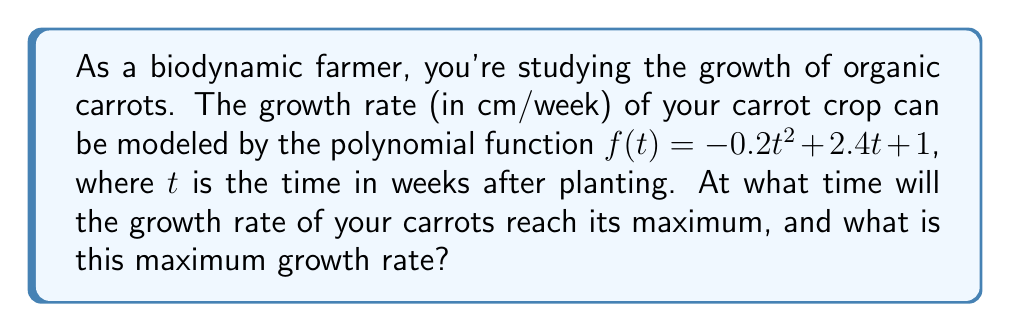Can you answer this question? To solve this problem, we'll follow these steps:

1) The growth rate function is given by $f(t) = -0.2t^2 + 2.4t + 1$. This is a quadratic function, and its graph is a parabola that opens downward (because the coefficient of $t^2$ is negative).

2) The maximum point of a parabola occurs at the vertex. For a quadratic function in the form $f(t) = at^2 + bt + c$, the t-coordinate of the vertex is given by $t = -\frac{b}{2a}$.

3) In our case, $a = -0.2$ and $b = 2.4$. Let's calculate the t-coordinate of the vertex:

   $t = -\frac{2.4}{2(-0.2)} = -\frac{2.4}{-0.4} = 6$

4) This means the growth rate reaches its maximum 6 weeks after planting.

5) To find the maximum growth rate, we need to calculate $f(6)$:

   $f(6) = -0.2(6)^2 + 2.4(6) + 1$
   $= -0.2(36) + 14.4 + 1$
   $= -7.2 + 14.4 + 1$
   $= 8.2$

Therefore, the maximum growth rate is 8.2 cm/week.
Answer: 6 weeks; 8.2 cm/week 